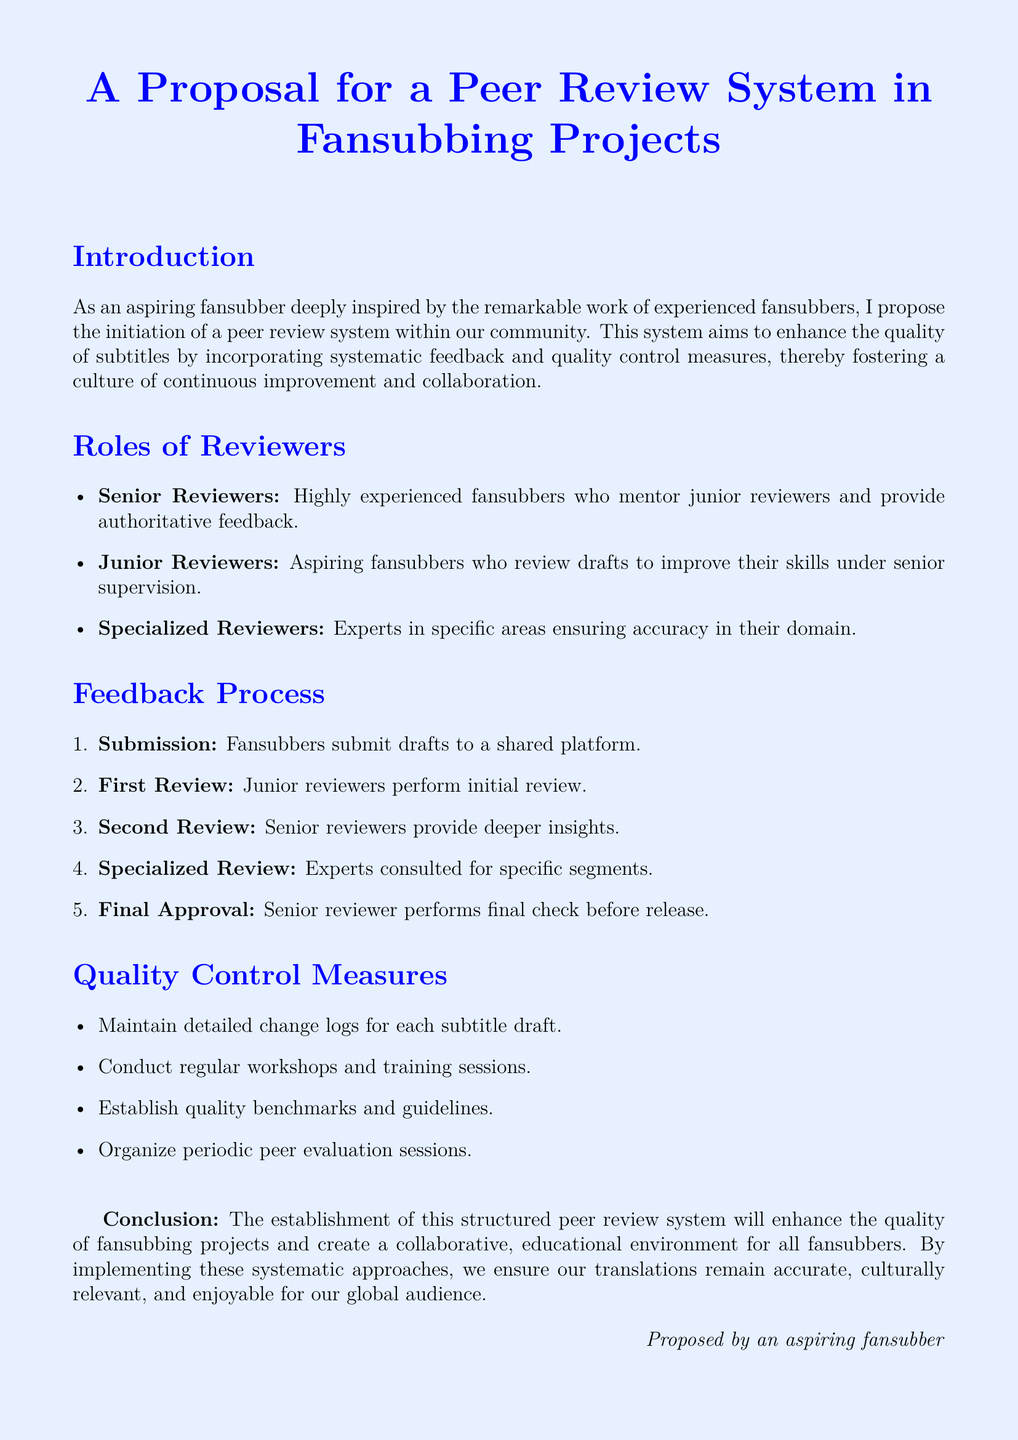what is the title of the document? The title clearly states the subject matter of the document, which is a proposal for a peer review system within fansubbing projects.
Answer: A Proposal for a Peer Review System in Fansubbing Projects who are the three types of reviewers mentioned? The document specifically lists three categories of reviewers, highlighting their roles in the feedback process.
Answer: Senior Reviewers, Junior Reviewers, Specialized Reviewers what is the first step in the feedback process? The feedback process is organized into several steps, and the first one is crucial for initiating the review.
Answer: Submission how often should peer evaluation sessions be organized? The quality control measures suggest organizing sessions to assess the work and share feedback, ensuring continuous improvement of the projects.
Answer: Periodic who performs the final check before release? The document specifies the reviewer responsible for the final approval stage prior to releasing the subtitles.
Answer: Senior Reviewer what is one quality control measure mentioned in the document? The document outlines several strategies to maintain quality in fansubbing projects, highlighting one specific measure.
Answer: Maintain detailed change logs for each subtitle draft what is the purpose of the proposed peer review system? The introduction states the primary goal of implementing this system within the fansubbing community.
Answer: Enhance the quality of subtitles 